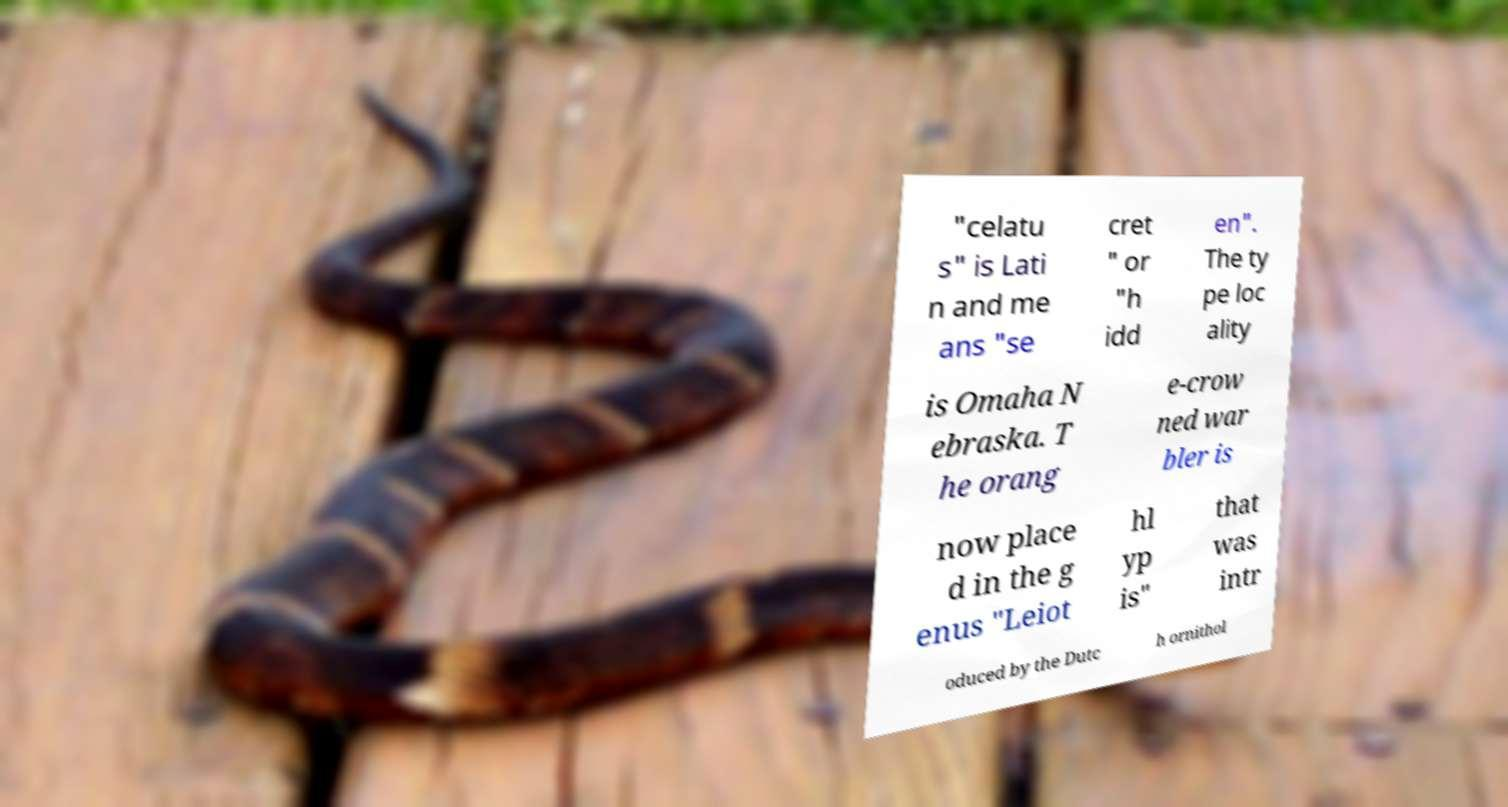What messages or text are displayed in this image? I need them in a readable, typed format. "celatu s" is Lati n and me ans "se cret " or "h idd en". The ty pe loc ality is Omaha N ebraska. T he orang e-crow ned war bler is now place d in the g enus "Leiot hl yp is" that was intr oduced by the Dutc h ornithol 